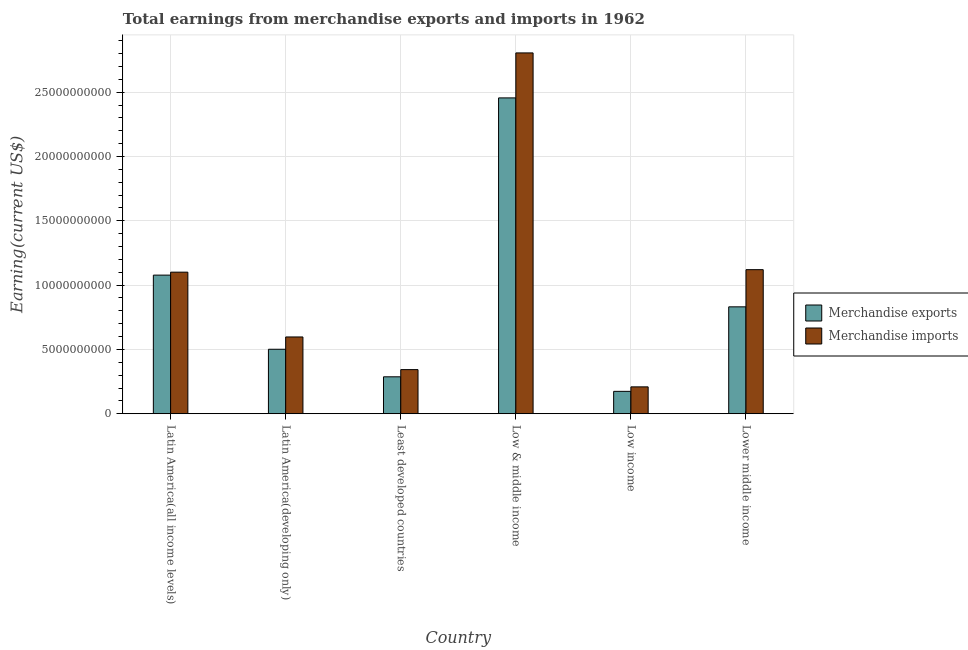How many groups of bars are there?
Keep it short and to the point. 6. Are the number of bars per tick equal to the number of legend labels?
Offer a terse response. Yes. How many bars are there on the 1st tick from the left?
Ensure brevity in your answer.  2. How many bars are there on the 1st tick from the right?
Ensure brevity in your answer.  2. What is the label of the 4th group of bars from the left?
Offer a terse response. Low & middle income. What is the earnings from merchandise exports in Low & middle income?
Provide a short and direct response. 2.46e+1. Across all countries, what is the maximum earnings from merchandise imports?
Keep it short and to the point. 2.81e+1. Across all countries, what is the minimum earnings from merchandise imports?
Make the answer very short. 2.09e+09. In which country was the earnings from merchandise exports maximum?
Provide a succinct answer. Low & middle income. In which country was the earnings from merchandise imports minimum?
Your answer should be very brief. Low income. What is the total earnings from merchandise imports in the graph?
Provide a short and direct response. 6.18e+1. What is the difference between the earnings from merchandise imports in Least developed countries and that in Low & middle income?
Provide a succinct answer. -2.46e+1. What is the difference between the earnings from merchandise imports in Lower middle income and the earnings from merchandise exports in Low & middle income?
Ensure brevity in your answer.  -1.34e+1. What is the average earnings from merchandise imports per country?
Ensure brevity in your answer.  1.03e+1. What is the difference between the earnings from merchandise imports and earnings from merchandise exports in Latin America(all income levels)?
Your answer should be very brief. 2.29e+08. In how many countries, is the earnings from merchandise exports greater than 1000000000 US$?
Provide a short and direct response. 6. What is the ratio of the earnings from merchandise imports in Latin America(all income levels) to that in Latin America(developing only)?
Provide a short and direct response. 1.84. Is the difference between the earnings from merchandise exports in Latin America(all income levels) and Lower middle income greater than the difference between the earnings from merchandise imports in Latin America(all income levels) and Lower middle income?
Offer a terse response. Yes. What is the difference between the highest and the second highest earnings from merchandise imports?
Offer a terse response. 1.69e+1. What is the difference between the highest and the lowest earnings from merchandise imports?
Your answer should be very brief. 2.60e+1. Is the sum of the earnings from merchandise exports in Latin America(all income levels) and Least developed countries greater than the maximum earnings from merchandise imports across all countries?
Provide a short and direct response. No. Are all the bars in the graph horizontal?
Give a very brief answer. No. What is the difference between two consecutive major ticks on the Y-axis?
Provide a short and direct response. 5.00e+09. Does the graph contain grids?
Keep it short and to the point. Yes. What is the title of the graph?
Make the answer very short. Total earnings from merchandise exports and imports in 1962. What is the label or title of the Y-axis?
Your response must be concise. Earning(current US$). What is the Earning(current US$) in Merchandise exports in Latin America(all income levels)?
Your answer should be compact. 1.08e+1. What is the Earning(current US$) in Merchandise imports in Latin America(all income levels)?
Offer a very short reply. 1.10e+1. What is the Earning(current US$) in Merchandise exports in Latin America(developing only)?
Keep it short and to the point. 5.01e+09. What is the Earning(current US$) of Merchandise imports in Latin America(developing only)?
Keep it short and to the point. 5.97e+09. What is the Earning(current US$) in Merchandise exports in Least developed countries?
Make the answer very short. 2.87e+09. What is the Earning(current US$) of Merchandise imports in Least developed countries?
Provide a succinct answer. 3.43e+09. What is the Earning(current US$) of Merchandise exports in Low & middle income?
Provide a succinct answer. 2.46e+1. What is the Earning(current US$) of Merchandise imports in Low & middle income?
Offer a very short reply. 2.81e+1. What is the Earning(current US$) in Merchandise exports in Low income?
Offer a terse response. 1.74e+09. What is the Earning(current US$) in Merchandise imports in Low income?
Provide a short and direct response. 2.09e+09. What is the Earning(current US$) of Merchandise exports in Lower middle income?
Make the answer very short. 8.31e+09. What is the Earning(current US$) of Merchandise imports in Lower middle income?
Offer a very short reply. 1.12e+1. Across all countries, what is the maximum Earning(current US$) in Merchandise exports?
Provide a succinct answer. 2.46e+1. Across all countries, what is the maximum Earning(current US$) in Merchandise imports?
Give a very brief answer. 2.81e+1. Across all countries, what is the minimum Earning(current US$) in Merchandise exports?
Ensure brevity in your answer.  1.74e+09. Across all countries, what is the minimum Earning(current US$) in Merchandise imports?
Provide a succinct answer. 2.09e+09. What is the total Earning(current US$) in Merchandise exports in the graph?
Offer a terse response. 5.33e+1. What is the total Earning(current US$) of Merchandise imports in the graph?
Make the answer very short. 6.18e+1. What is the difference between the Earning(current US$) in Merchandise exports in Latin America(all income levels) and that in Latin America(developing only)?
Offer a very short reply. 5.77e+09. What is the difference between the Earning(current US$) of Merchandise imports in Latin America(all income levels) and that in Latin America(developing only)?
Provide a short and direct response. 5.04e+09. What is the difference between the Earning(current US$) in Merchandise exports in Latin America(all income levels) and that in Least developed countries?
Offer a very short reply. 7.91e+09. What is the difference between the Earning(current US$) of Merchandise imports in Latin America(all income levels) and that in Least developed countries?
Give a very brief answer. 7.58e+09. What is the difference between the Earning(current US$) in Merchandise exports in Latin America(all income levels) and that in Low & middle income?
Your answer should be compact. -1.38e+1. What is the difference between the Earning(current US$) of Merchandise imports in Latin America(all income levels) and that in Low & middle income?
Give a very brief answer. -1.70e+1. What is the difference between the Earning(current US$) in Merchandise exports in Latin America(all income levels) and that in Low income?
Give a very brief answer. 9.04e+09. What is the difference between the Earning(current US$) of Merchandise imports in Latin America(all income levels) and that in Low income?
Make the answer very short. 8.92e+09. What is the difference between the Earning(current US$) in Merchandise exports in Latin America(all income levels) and that in Lower middle income?
Your answer should be compact. 2.47e+09. What is the difference between the Earning(current US$) of Merchandise imports in Latin America(all income levels) and that in Lower middle income?
Give a very brief answer. -1.94e+08. What is the difference between the Earning(current US$) in Merchandise exports in Latin America(developing only) and that in Least developed countries?
Give a very brief answer. 2.14e+09. What is the difference between the Earning(current US$) of Merchandise imports in Latin America(developing only) and that in Least developed countries?
Provide a succinct answer. 2.54e+09. What is the difference between the Earning(current US$) of Merchandise exports in Latin America(developing only) and that in Low & middle income?
Offer a terse response. -1.95e+1. What is the difference between the Earning(current US$) in Merchandise imports in Latin America(developing only) and that in Low & middle income?
Your response must be concise. -2.21e+1. What is the difference between the Earning(current US$) in Merchandise exports in Latin America(developing only) and that in Low income?
Provide a short and direct response. 3.27e+09. What is the difference between the Earning(current US$) in Merchandise imports in Latin America(developing only) and that in Low income?
Provide a succinct answer. 3.88e+09. What is the difference between the Earning(current US$) in Merchandise exports in Latin America(developing only) and that in Lower middle income?
Offer a very short reply. -3.30e+09. What is the difference between the Earning(current US$) in Merchandise imports in Latin America(developing only) and that in Lower middle income?
Offer a very short reply. -5.23e+09. What is the difference between the Earning(current US$) in Merchandise exports in Least developed countries and that in Low & middle income?
Your answer should be very brief. -2.17e+1. What is the difference between the Earning(current US$) in Merchandise imports in Least developed countries and that in Low & middle income?
Provide a short and direct response. -2.46e+1. What is the difference between the Earning(current US$) of Merchandise exports in Least developed countries and that in Low income?
Your answer should be very brief. 1.13e+09. What is the difference between the Earning(current US$) of Merchandise imports in Least developed countries and that in Low income?
Offer a very short reply. 1.34e+09. What is the difference between the Earning(current US$) in Merchandise exports in Least developed countries and that in Lower middle income?
Your answer should be compact. -5.44e+09. What is the difference between the Earning(current US$) in Merchandise imports in Least developed countries and that in Lower middle income?
Your response must be concise. -7.77e+09. What is the difference between the Earning(current US$) in Merchandise exports in Low & middle income and that in Low income?
Keep it short and to the point. 2.28e+1. What is the difference between the Earning(current US$) of Merchandise imports in Low & middle income and that in Low income?
Give a very brief answer. 2.60e+1. What is the difference between the Earning(current US$) of Merchandise exports in Low & middle income and that in Lower middle income?
Ensure brevity in your answer.  1.62e+1. What is the difference between the Earning(current US$) of Merchandise imports in Low & middle income and that in Lower middle income?
Your answer should be compact. 1.69e+1. What is the difference between the Earning(current US$) of Merchandise exports in Low income and that in Lower middle income?
Offer a terse response. -6.57e+09. What is the difference between the Earning(current US$) in Merchandise imports in Low income and that in Lower middle income?
Your answer should be compact. -9.11e+09. What is the difference between the Earning(current US$) of Merchandise exports in Latin America(all income levels) and the Earning(current US$) of Merchandise imports in Latin America(developing only)?
Your answer should be very brief. 4.81e+09. What is the difference between the Earning(current US$) in Merchandise exports in Latin America(all income levels) and the Earning(current US$) in Merchandise imports in Least developed countries?
Your response must be concise. 7.35e+09. What is the difference between the Earning(current US$) in Merchandise exports in Latin America(all income levels) and the Earning(current US$) in Merchandise imports in Low & middle income?
Your answer should be compact. -1.73e+1. What is the difference between the Earning(current US$) of Merchandise exports in Latin America(all income levels) and the Earning(current US$) of Merchandise imports in Low income?
Provide a short and direct response. 8.69e+09. What is the difference between the Earning(current US$) in Merchandise exports in Latin America(all income levels) and the Earning(current US$) in Merchandise imports in Lower middle income?
Ensure brevity in your answer.  -4.23e+08. What is the difference between the Earning(current US$) in Merchandise exports in Latin America(developing only) and the Earning(current US$) in Merchandise imports in Least developed countries?
Provide a succinct answer. 1.58e+09. What is the difference between the Earning(current US$) of Merchandise exports in Latin America(developing only) and the Earning(current US$) of Merchandise imports in Low & middle income?
Keep it short and to the point. -2.30e+1. What is the difference between the Earning(current US$) in Merchandise exports in Latin America(developing only) and the Earning(current US$) in Merchandise imports in Low income?
Ensure brevity in your answer.  2.92e+09. What is the difference between the Earning(current US$) of Merchandise exports in Latin America(developing only) and the Earning(current US$) of Merchandise imports in Lower middle income?
Offer a terse response. -6.19e+09. What is the difference between the Earning(current US$) of Merchandise exports in Least developed countries and the Earning(current US$) of Merchandise imports in Low & middle income?
Provide a short and direct response. -2.52e+1. What is the difference between the Earning(current US$) of Merchandise exports in Least developed countries and the Earning(current US$) of Merchandise imports in Low income?
Offer a very short reply. 7.82e+08. What is the difference between the Earning(current US$) of Merchandise exports in Least developed countries and the Earning(current US$) of Merchandise imports in Lower middle income?
Offer a terse response. -8.33e+09. What is the difference between the Earning(current US$) of Merchandise exports in Low & middle income and the Earning(current US$) of Merchandise imports in Low income?
Your response must be concise. 2.25e+1. What is the difference between the Earning(current US$) of Merchandise exports in Low & middle income and the Earning(current US$) of Merchandise imports in Lower middle income?
Your answer should be compact. 1.34e+1. What is the difference between the Earning(current US$) in Merchandise exports in Low income and the Earning(current US$) in Merchandise imports in Lower middle income?
Offer a terse response. -9.46e+09. What is the average Earning(current US$) of Merchandise exports per country?
Keep it short and to the point. 8.88e+09. What is the average Earning(current US$) of Merchandise imports per country?
Make the answer very short. 1.03e+1. What is the difference between the Earning(current US$) of Merchandise exports and Earning(current US$) of Merchandise imports in Latin America(all income levels)?
Offer a very short reply. -2.29e+08. What is the difference between the Earning(current US$) of Merchandise exports and Earning(current US$) of Merchandise imports in Latin America(developing only)?
Make the answer very short. -9.56e+08. What is the difference between the Earning(current US$) of Merchandise exports and Earning(current US$) of Merchandise imports in Least developed countries?
Offer a very short reply. -5.59e+08. What is the difference between the Earning(current US$) in Merchandise exports and Earning(current US$) in Merchandise imports in Low & middle income?
Your response must be concise. -3.50e+09. What is the difference between the Earning(current US$) in Merchandise exports and Earning(current US$) in Merchandise imports in Low income?
Offer a very short reply. -3.50e+08. What is the difference between the Earning(current US$) of Merchandise exports and Earning(current US$) of Merchandise imports in Lower middle income?
Offer a terse response. -2.89e+09. What is the ratio of the Earning(current US$) in Merchandise exports in Latin America(all income levels) to that in Latin America(developing only)?
Keep it short and to the point. 2.15. What is the ratio of the Earning(current US$) in Merchandise imports in Latin America(all income levels) to that in Latin America(developing only)?
Make the answer very short. 1.84. What is the ratio of the Earning(current US$) in Merchandise exports in Latin America(all income levels) to that in Least developed countries?
Keep it short and to the point. 3.75. What is the ratio of the Earning(current US$) in Merchandise imports in Latin America(all income levels) to that in Least developed countries?
Your response must be concise. 3.21. What is the ratio of the Earning(current US$) in Merchandise exports in Latin America(all income levels) to that in Low & middle income?
Provide a short and direct response. 0.44. What is the ratio of the Earning(current US$) of Merchandise imports in Latin America(all income levels) to that in Low & middle income?
Provide a short and direct response. 0.39. What is the ratio of the Earning(current US$) in Merchandise exports in Latin America(all income levels) to that in Low income?
Your answer should be compact. 6.19. What is the ratio of the Earning(current US$) of Merchandise imports in Latin America(all income levels) to that in Low income?
Keep it short and to the point. 5.27. What is the ratio of the Earning(current US$) in Merchandise exports in Latin America(all income levels) to that in Lower middle income?
Provide a succinct answer. 1.3. What is the ratio of the Earning(current US$) of Merchandise imports in Latin America(all income levels) to that in Lower middle income?
Your answer should be very brief. 0.98. What is the ratio of the Earning(current US$) of Merchandise exports in Latin America(developing only) to that in Least developed countries?
Your answer should be very brief. 1.75. What is the ratio of the Earning(current US$) of Merchandise imports in Latin America(developing only) to that in Least developed countries?
Make the answer very short. 1.74. What is the ratio of the Earning(current US$) of Merchandise exports in Latin America(developing only) to that in Low & middle income?
Provide a short and direct response. 0.2. What is the ratio of the Earning(current US$) in Merchandise imports in Latin America(developing only) to that in Low & middle income?
Provide a succinct answer. 0.21. What is the ratio of the Earning(current US$) of Merchandise exports in Latin America(developing only) to that in Low income?
Provide a short and direct response. 2.88. What is the ratio of the Earning(current US$) in Merchandise imports in Latin America(developing only) to that in Low income?
Keep it short and to the point. 2.86. What is the ratio of the Earning(current US$) in Merchandise exports in Latin America(developing only) to that in Lower middle income?
Provide a short and direct response. 0.6. What is the ratio of the Earning(current US$) in Merchandise imports in Latin America(developing only) to that in Lower middle income?
Your answer should be compact. 0.53. What is the ratio of the Earning(current US$) in Merchandise exports in Least developed countries to that in Low & middle income?
Ensure brevity in your answer.  0.12. What is the ratio of the Earning(current US$) of Merchandise imports in Least developed countries to that in Low & middle income?
Give a very brief answer. 0.12. What is the ratio of the Earning(current US$) of Merchandise exports in Least developed countries to that in Low income?
Your answer should be very brief. 1.65. What is the ratio of the Earning(current US$) in Merchandise imports in Least developed countries to that in Low income?
Your answer should be very brief. 1.64. What is the ratio of the Earning(current US$) in Merchandise exports in Least developed countries to that in Lower middle income?
Your answer should be compact. 0.35. What is the ratio of the Earning(current US$) in Merchandise imports in Least developed countries to that in Lower middle income?
Give a very brief answer. 0.31. What is the ratio of the Earning(current US$) of Merchandise exports in Low & middle income to that in Low income?
Your answer should be compact. 14.11. What is the ratio of the Earning(current US$) of Merchandise imports in Low & middle income to that in Low income?
Offer a terse response. 13.42. What is the ratio of the Earning(current US$) in Merchandise exports in Low & middle income to that in Lower middle income?
Make the answer very short. 2.95. What is the ratio of the Earning(current US$) in Merchandise imports in Low & middle income to that in Lower middle income?
Keep it short and to the point. 2.5. What is the ratio of the Earning(current US$) in Merchandise exports in Low income to that in Lower middle income?
Offer a terse response. 0.21. What is the ratio of the Earning(current US$) of Merchandise imports in Low income to that in Lower middle income?
Your answer should be compact. 0.19. What is the difference between the highest and the second highest Earning(current US$) in Merchandise exports?
Provide a succinct answer. 1.38e+1. What is the difference between the highest and the second highest Earning(current US$) in Merchandise imports?
Make the answer very short. 1.69e+1. What is the difference between the highest and the lowest Earning(current US$) of Merchandise exports?
Provide a short and direct response. 2.28e+1. What is the difference between the highest and the lowest Earning(current US$) of Merchandise imports?
Give a very brief answer. 2.60e+1. 